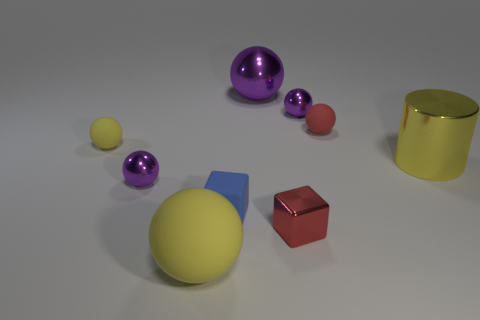Subtract all purple balls. How many were subtracted if there are1purple balls left? 2 Subtract all green cylinders. How many purple spheres are left? 3 Subtract all yellow balls. How many balls are left? 4 Subtract all big purple metal balls. How many balls are left? 5 Subtract all blue spheres. Subtract all green cylinders. How many spheres are left? 6 Subtract all spheres. How many objects are left? 3 Subtract all red shiny cubes. Subtract all small red matte cylinders. How many objects are left? 8 Add 6 big objects. How many big objects are left? 9 Add 9 green balls. How many green balls exist? 9 Subtract 0 green cubes. How many objects are left? 9 